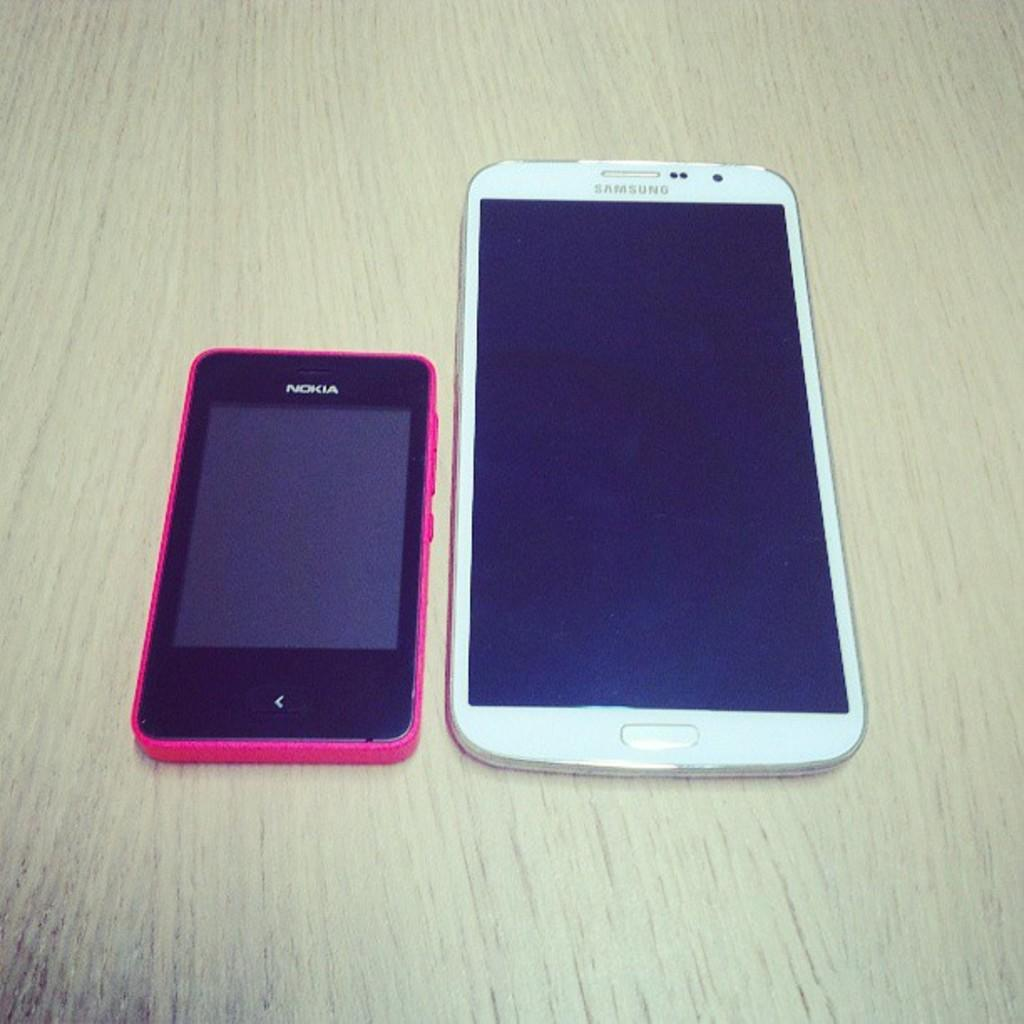Provide a one-sentence caption for the provided image. a Nokia phone and Samsung tablet (or phone?).. 